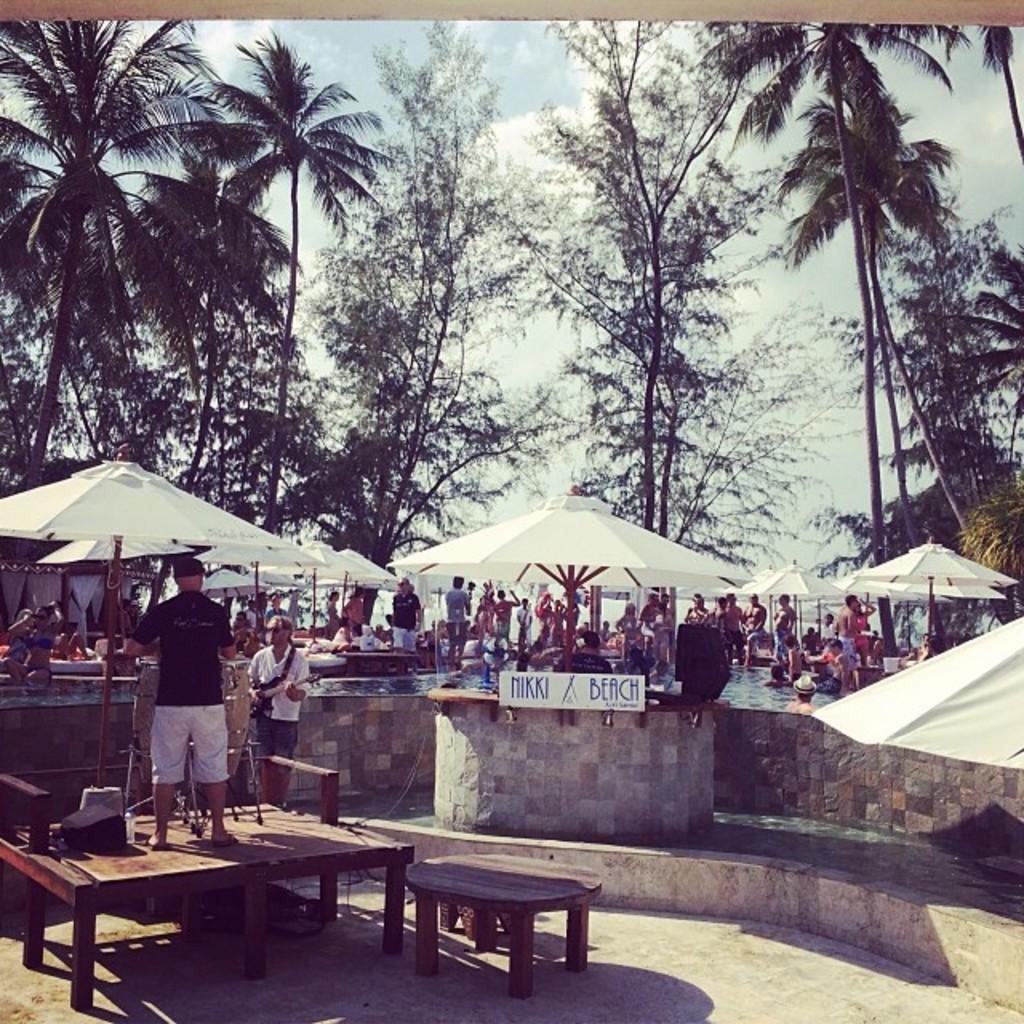Please provide a concise description of this image. there is outside there are so many trees are there some of people are there in the water and some of people are standing on the floor and some of people are standing on the table. 